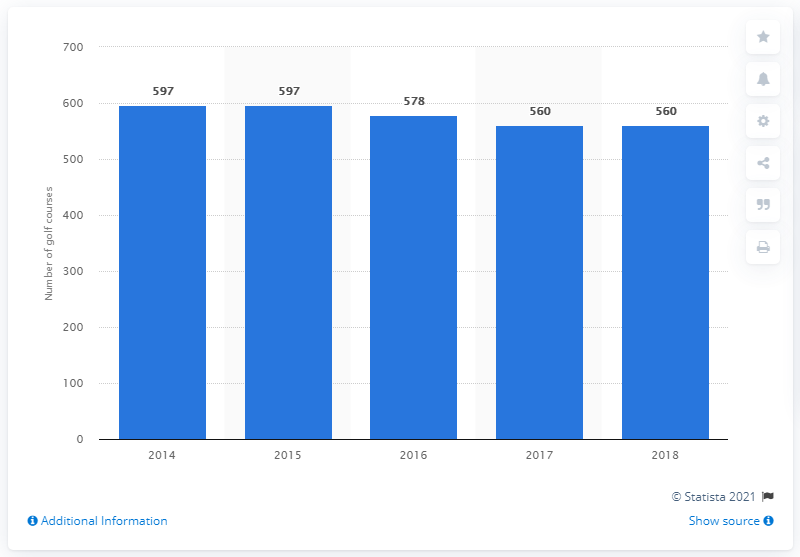What trend does this graph show about the number of golf courses in Scotland from 2014 to 2018? The graph shows a slight decrease in the number of golf courses in Scotland over the period from 2014 to 2018, starting at 597 and falling to 560 courses. 